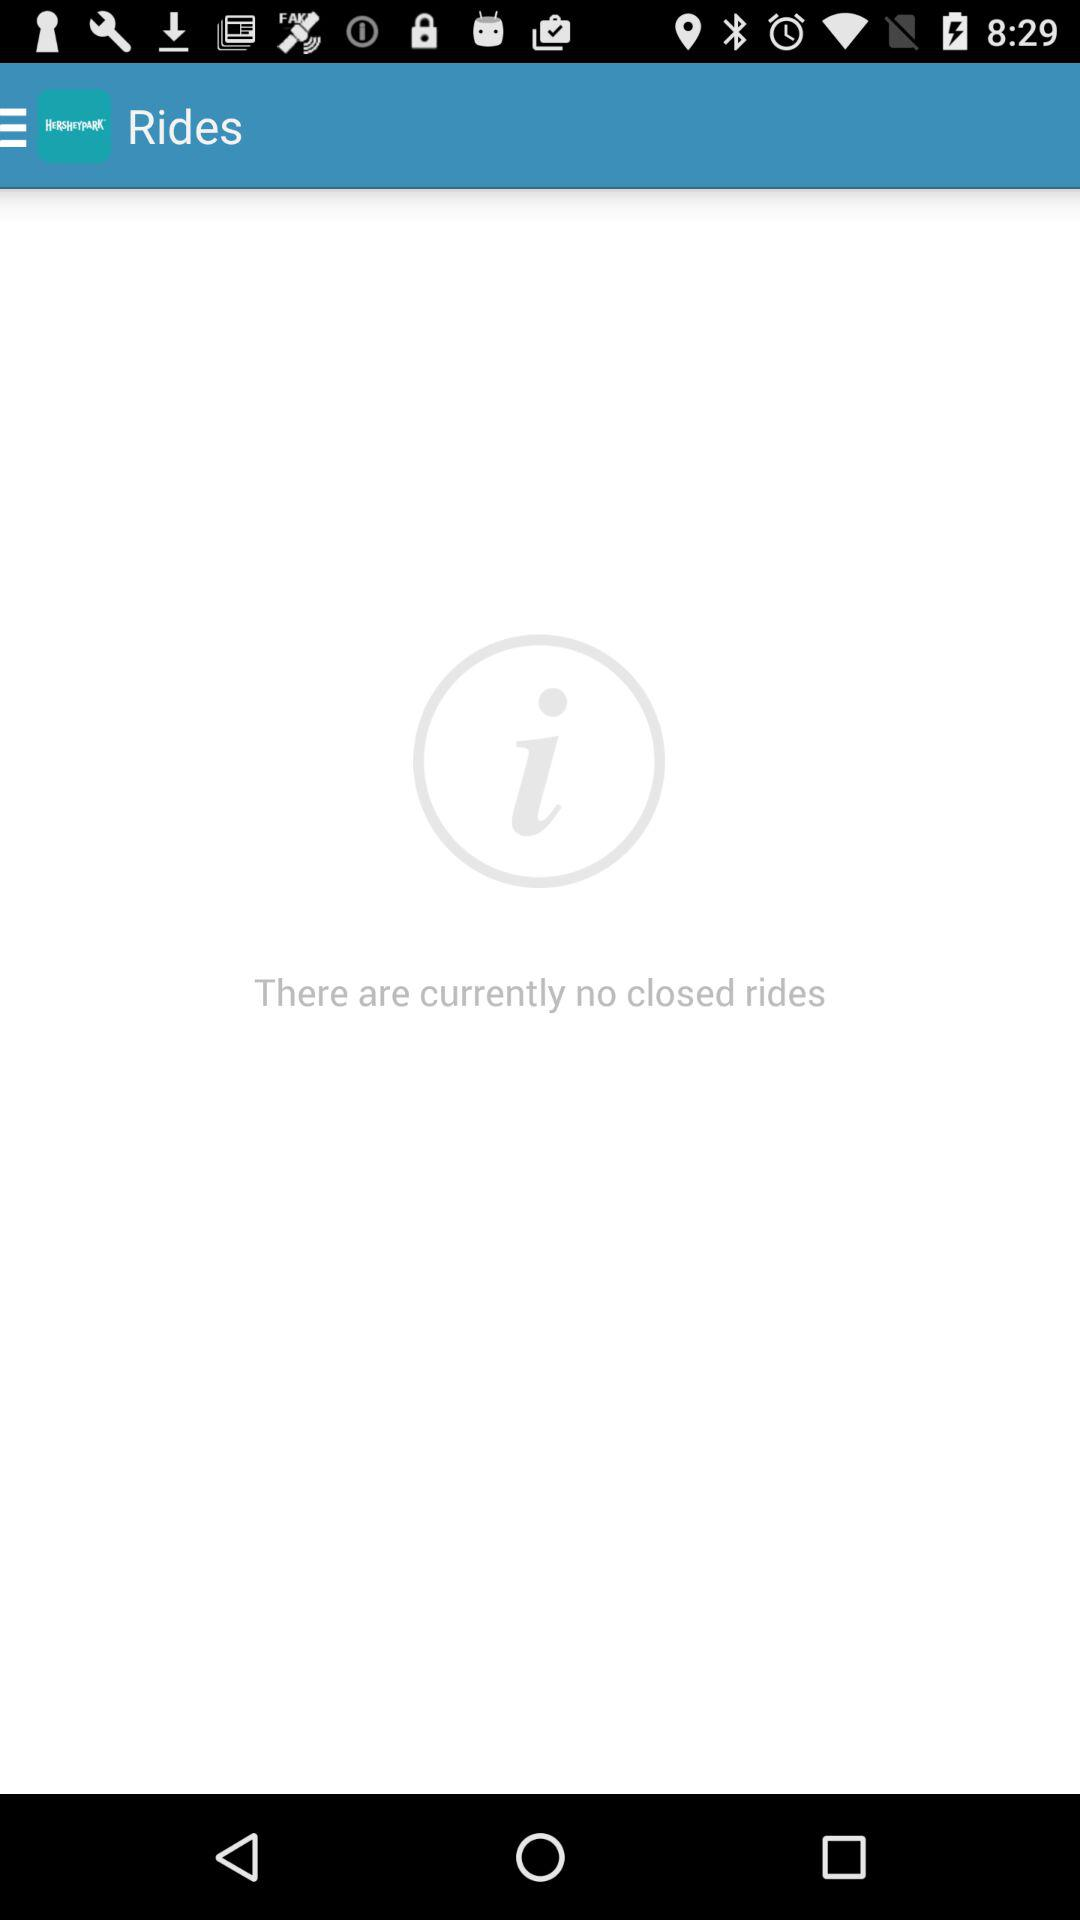What is the name of the application? The application name is "HERSHEYPARK". 